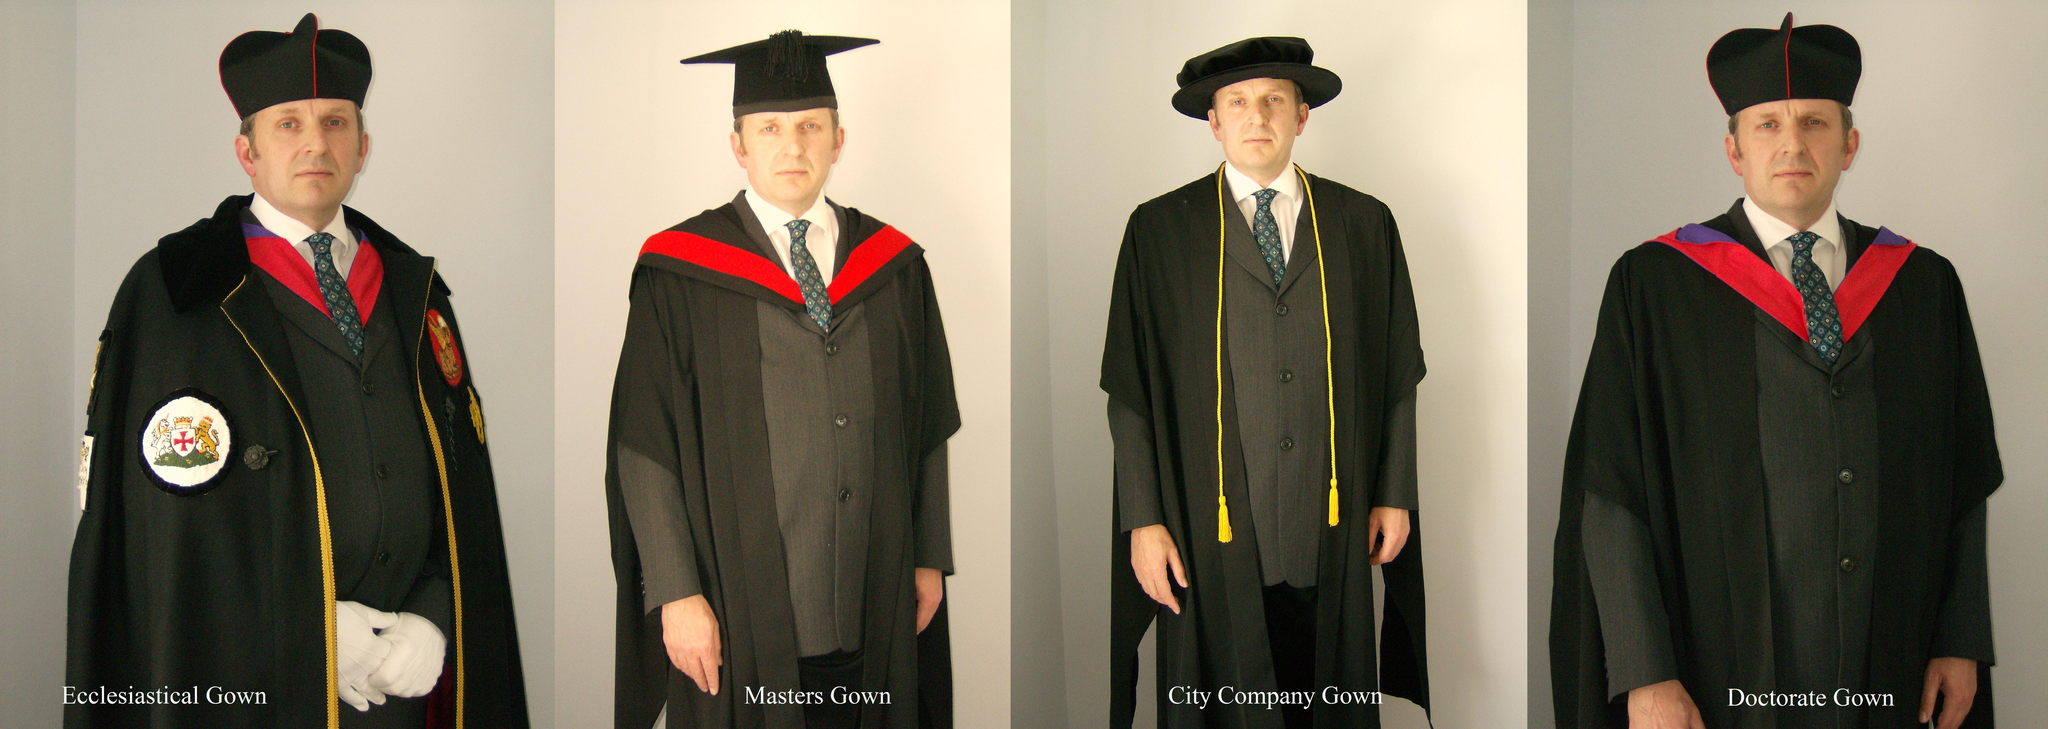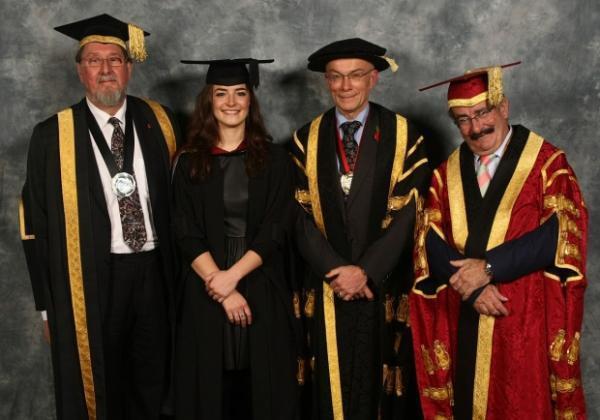The first image is the image on the left, the second image is the image on the right. Examine the images to the left and right. Is the description "The right image contains exactly four humans wearing graduation uniforms." accurate? Answer yes or no. Yes. The first image is the image on the left, the second image is the image on the right. Considering the images on both sides, is "There are at least eight people in total." valid? Answer yes or no. Yes. 